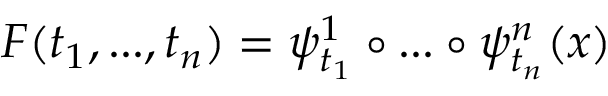<formula> <loc_0><loc_0><loc_500><loc_500>F ( t _ { 1 } , \dots , t _ { n } ) = \psi _ { t _ { 1 } } ^ { 1 } \circ \dots \circ \psi _ { t _ { n } } ^ { n } ( x )</formula> 